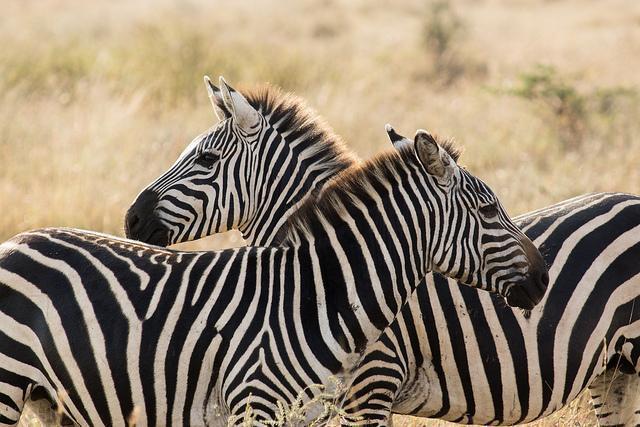How many zebras are in this picture?
Give a very brief answer. 2. How many zebras can you see?
Give a very brief answer. 2. 